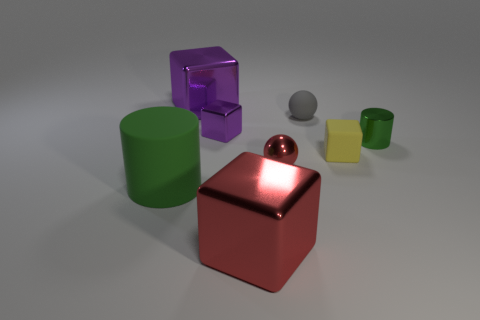What colors are the objects in the image? The objects present a variety of colors: there's a green cylinder, a red sphere, a metallic cube which appears to be silver, a purple transparent cube, a small gray sphere, and a smaller yellow cube. 